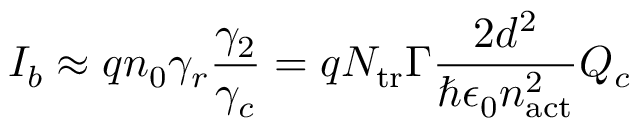<formula> <loc_0><loc_0><loc_500><loc_500>I _ { b } \approx q n _ { 0 } \gamma _ { r } \frac { \gamma _ { 2 } } { \gamma _ { c } } = q N _ { t r } \Gamma \frac { 2 d ^ { 2 } } { \hbar { \epsilon } _ { 0 } n _ { a c t } ^ { 2 } } Q _ { c }</formula> 